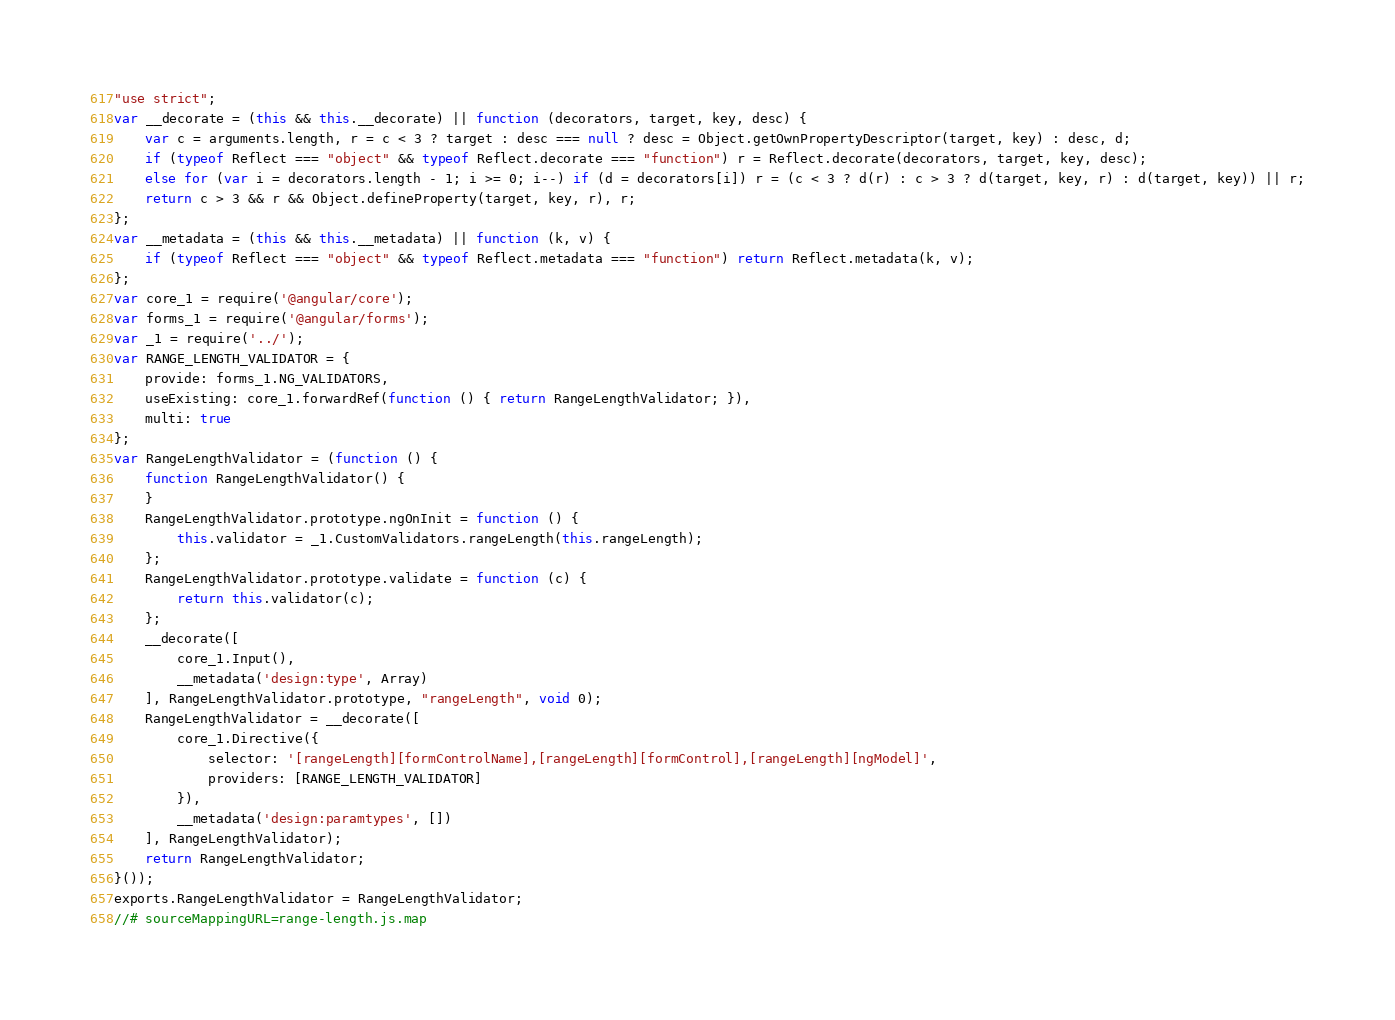<code> <loc_0><loc_0><loc_500><loc_500><_JavaScript_>"use strict";
var __decorate = (this && this.__decorate) || function (decorators, target, key, desc) {
    var c = arguments.length, r = c < 3 ? target : desc === null ? desc = Object.getOwnPropertyDescriptor(target, key) : desc, d;
    if (typeof Reflect === "object" && typeof Reflect.decorate === "function") r = Reflect.decorate(decorators, target, key, desc);
    else for (var i = decorators.length - 1; i >= 0; i--) if (d = decorators[i]) r = (c < 3 ? d(r) : c > 3 ? d(target, key, r) : d(target, key)) || r;
    return c > 3 && r && Object.defineProperty(target, key, r), r;
};
var __metadata = (this && this.__metadata) || function (k, v) {
    if (typeof Reflect === "object" && typeof Reflect.metadata === "function") return Reflect.metadata(k, v);
};
var core_1 = require('@angular/core');
var forms_1 = require('@angular/forms');
var _1 = require('../');
var RANGE_LENGTH_VALIDATOR = {
    provide: forms_1.NG_VALIDATORS,
    useExisting: core_1.forwardRef(function () { return RangeLengthValidator; }),
    multi: true
};
var RangeLengthValidator = (function () {
    function RangeLengthValidator() {
    }
    RangeLengthValidator.prototype.ngOnInit = function () {
        this.validator = _1.CustomValidators.rangeLength(this.rangeLength);
    };
    RangeLengthValidator.prototype.validate = function (c) {
        return this.validator(c);
    };
    __decorate([
        core_1.Input(), 
        __metadata('design:type', Array)
    ], RangeLengthValidator.prototype, "rangeLength", void 0);
    RangeLengthValidator = __decorate([
        core_1.Directive({
            selector: '[rangeLength][formControlName],[rangeLength][formControl],[rangeLength][ngModel]',
            providers: [RANGE_LENGTH_VALIDATOR]
        }), 
        __metadata('design:paramtypes', [])
    ], RangeLengthValidator);
    return RangeLengthValidator;
}());
exports.RangeLengthValidator = RangeLengthValidator;
//# sourceMappingURL=range-length.js.map</code> 